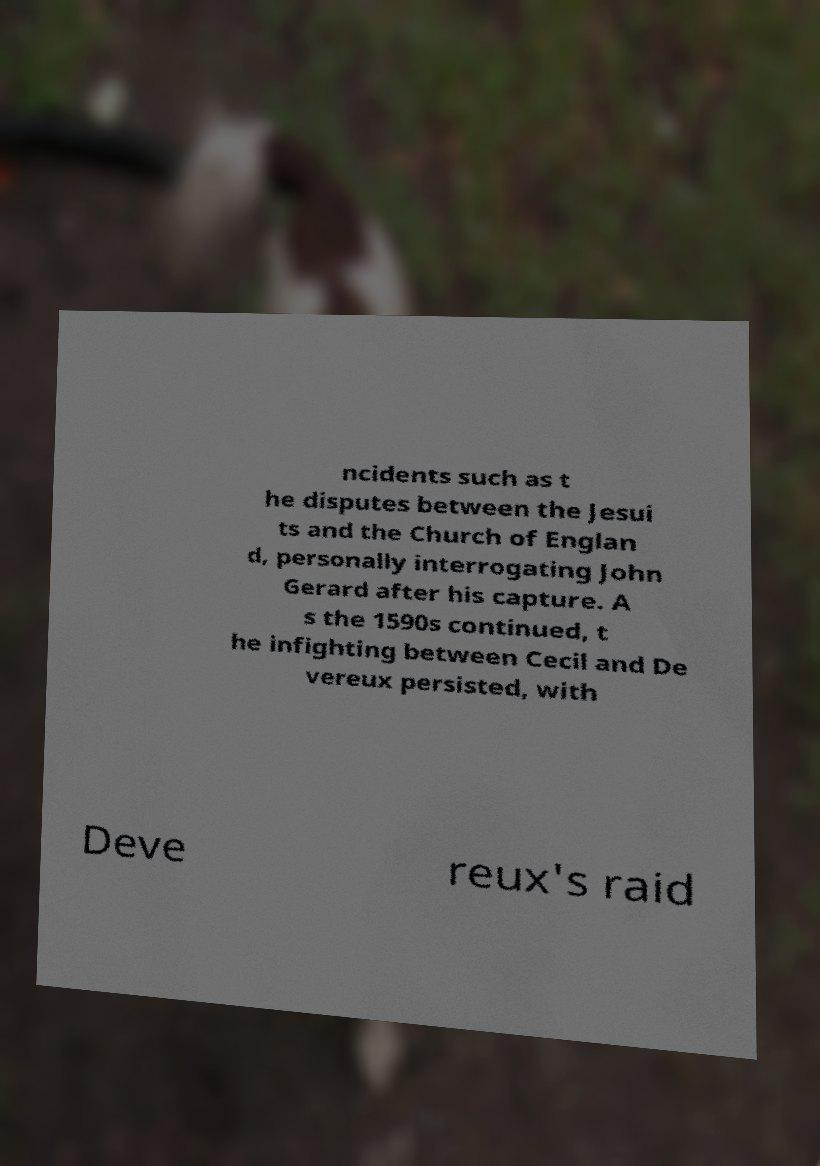For documentation purposes, I need the text within this image transcribed. Could you provide that? ncidents such as t he disputes between the Jesui ts and the Church of Englan d, personally interrogating John Gerard after his capture. A s the 1590s continued, t he infighting between Cecil and De vereux persisted, with Deve reux's raid 